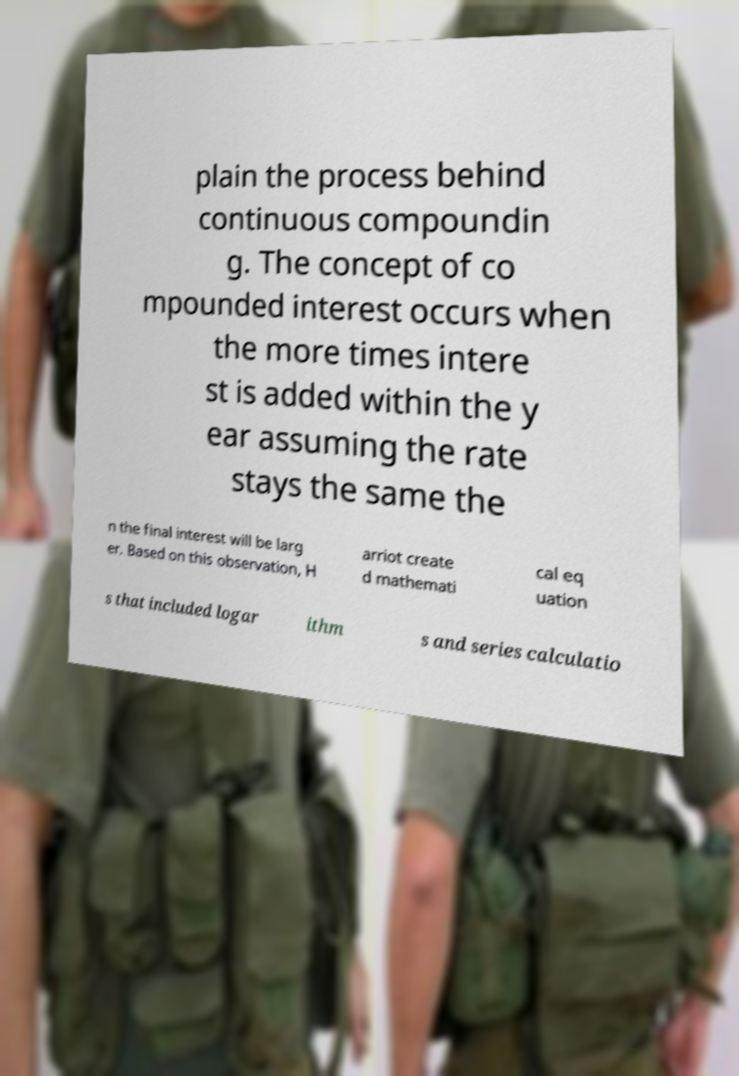Could you assist in decoding the text presented in this image and type it out clearly? plain the process behind continuous compoundin g. The concept of co mpounded interest occurs when the more times intere st is added within the y ear assuming the rate stays the same the n the final interest will be larg er. Based on this observation, H arriot create d mathemati cal eq uation s that included logar ithm s and series calculatio 